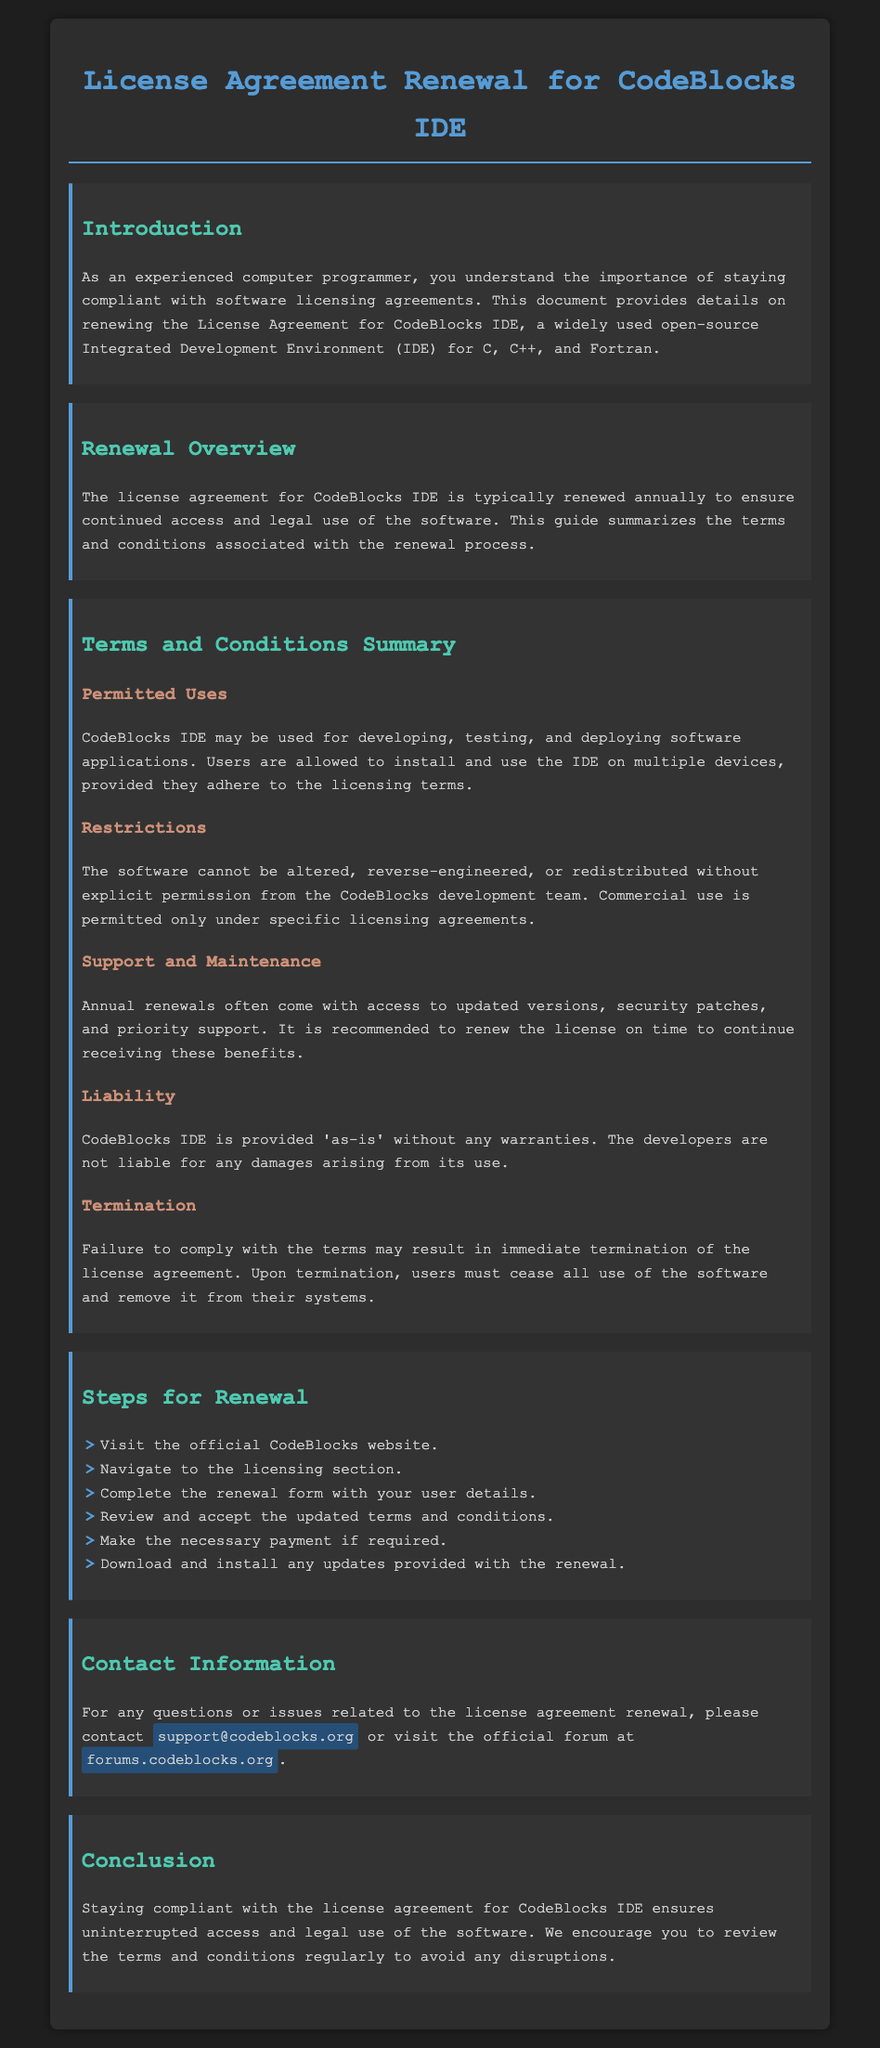What is the main subject of the document? The main subject of the document is the renewal of the license agreement for CodeBlocks IDE.
Answer: License Agreement Renewal How often is the license agreement renewed? The document specifies that the license agreement is renewed annually.
Answer: Annually What email address can users contact for support? The document provides a support email address for inquiries related to the license agreement renewal.
Answer: support@codeblocks.org What must users do if they do not comply with the terms? The document states that failure to comply may lead to a specific consequence outlined in the termination section.
Answer: Termination What is included in annual renewals? The document mentions benefits that come with renewing the license annually.
Answer: Updated versions, security patches, and priority support What is the first step for renewing the license? The document lists a sequence of steps for renewal, starting with a specific action.
Answer: Visit the official CodeBlocks website Can the software be altered without permission? The licensing terms explicitly mention conditions regarding altering the software.
Answer: No What is the nature of the liability stated in the document? The document outlines the developers' position regarding liability related to the software usage.
Answer: 'As-is' without any warranties What action must be taken upon termination of the license? The document specifies what users need to do if their license is terminated.
Answer: Cease all use of the software 